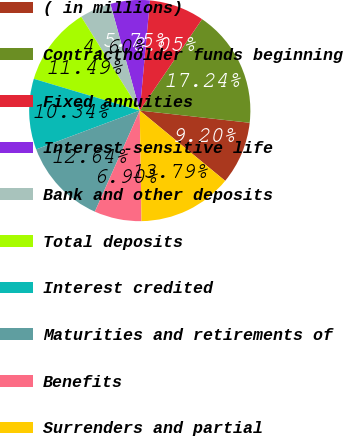Convert chart to OTSL. <chart><loc_0><loc_0><loc_500><loc_500><pie_chart><fcel>( in millions)<fcel>Contractholder funds beginning<fcel>Fixed annuities<fcel>Interest-sensitive life<fcel>Bank and other deposits<fcel>Total deposits<fcel>Interest credited<fcel>Maturities and retirements of<fcel>Benefits<fcel>Surrenders and partial<nl><fcel>9.2%<fcel>17.24%<fcel>8.05%<fcel>5.75%<fcel>4.6%<fcel>11.49%<fcel>10.34%<fcel>12.64%<fcel>6.9%<fcel>13.79%<nl></chart> 